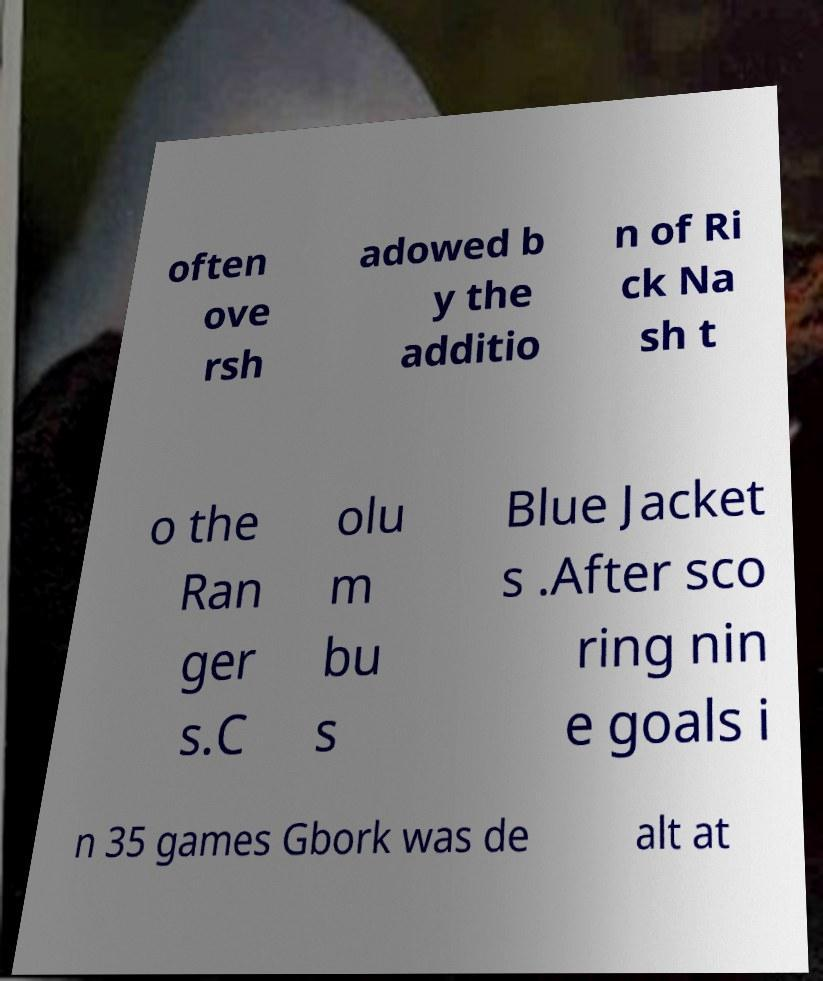For documentation purposes, I need the text within this image transcribed. Could you provide that? often ove rsh adowed b y the additio n of Ri ck Na sh t o the Ran ger s.C olu m bu s Blue Jacket s .After sco ring nin e goals i n 35 games Gbork was de alt at 